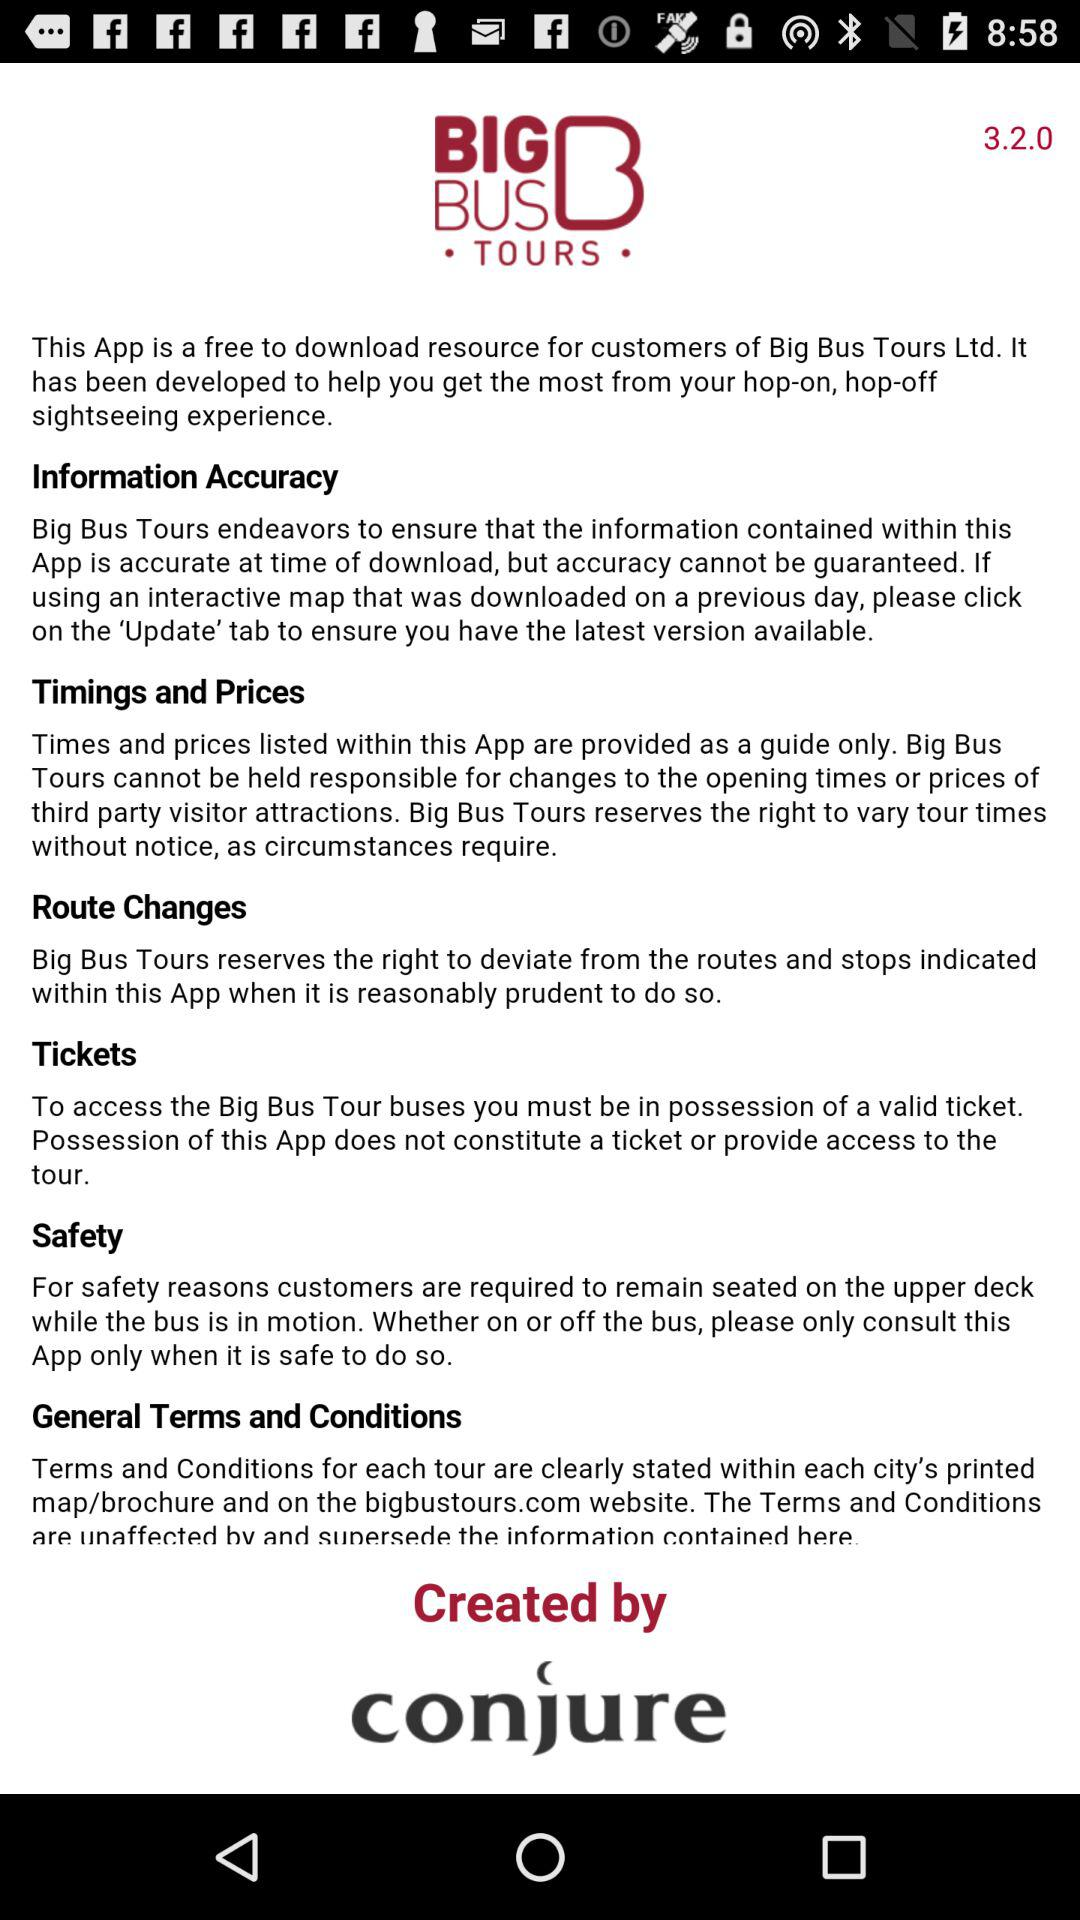By whom was the app created? The app was created by conjure. 